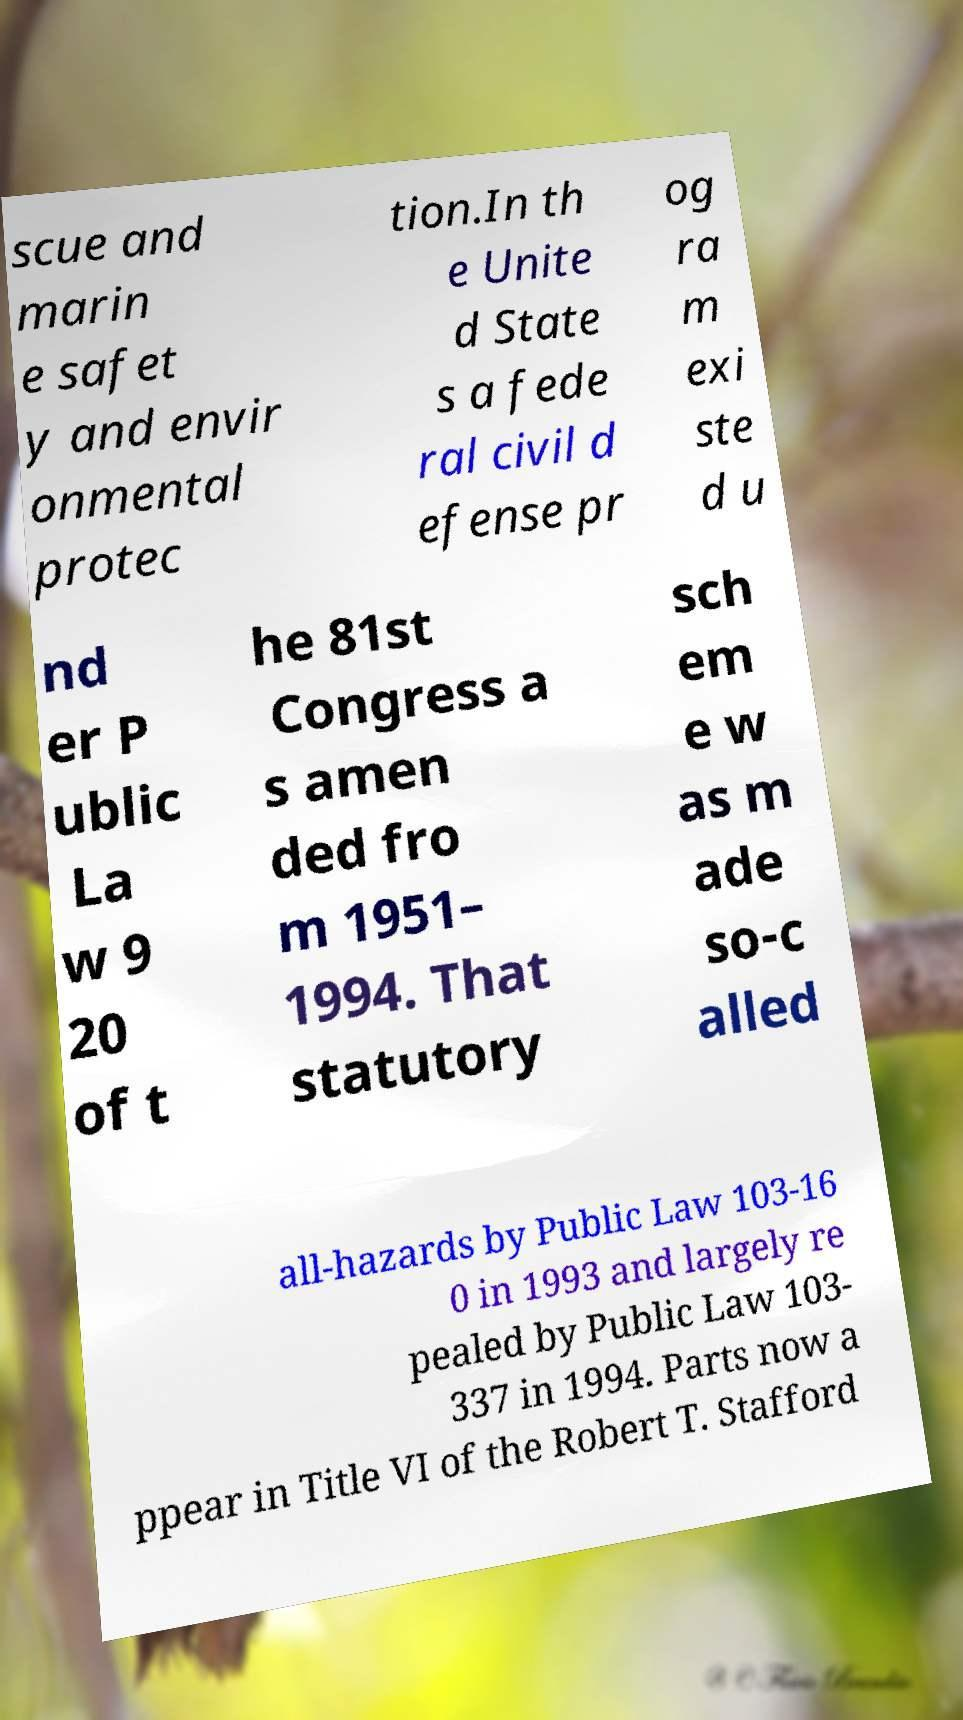Can you read and provide the text displayed in the image?This photo seems to have some interesting text. Can you extract and type it out for me? scue and marin e safet y and envir onmental protec tion.In th e Unite d State s a fede ral civil d efense pr og ra m exi ste d u nd er P ublic La w 9 20 of t he 81st Congress a s amen ded fro m 1951– 1994. That statutory sch em e w as m ade so-c alled all-hazards by Public Law 103-16 0 in 1993 and largely re pealed by Public Law 103- 337 in 1994. Parts now a ppear in Title VI of the Robert T. Stafford 